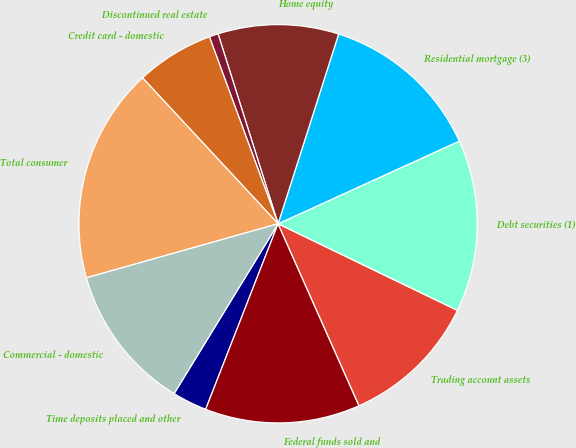<chart> <loc_0><loc_0><loc_500><loc_500><pie_chart><fcel>Time deposits placed and other<fcel>Federal funds sold and<fcel>Trading account assets<fcel>Debt securities (1)<fcel>Residential mortgage (3)<fcel>Home equity<fcel>Discontinued real estate<fcel>Credit card - domestic<fcel>Total consumer<fcel>Commercial - domestic<nl><fcel>2.82%<fcel>12.58%<fcel>11.18%<fcel>13.97%<fcel>13.27%<fcel>9.79%<fcel>0.73%<fcel>6.31%<fcel>17.46%<fcel>11.88%<nl></chart> 